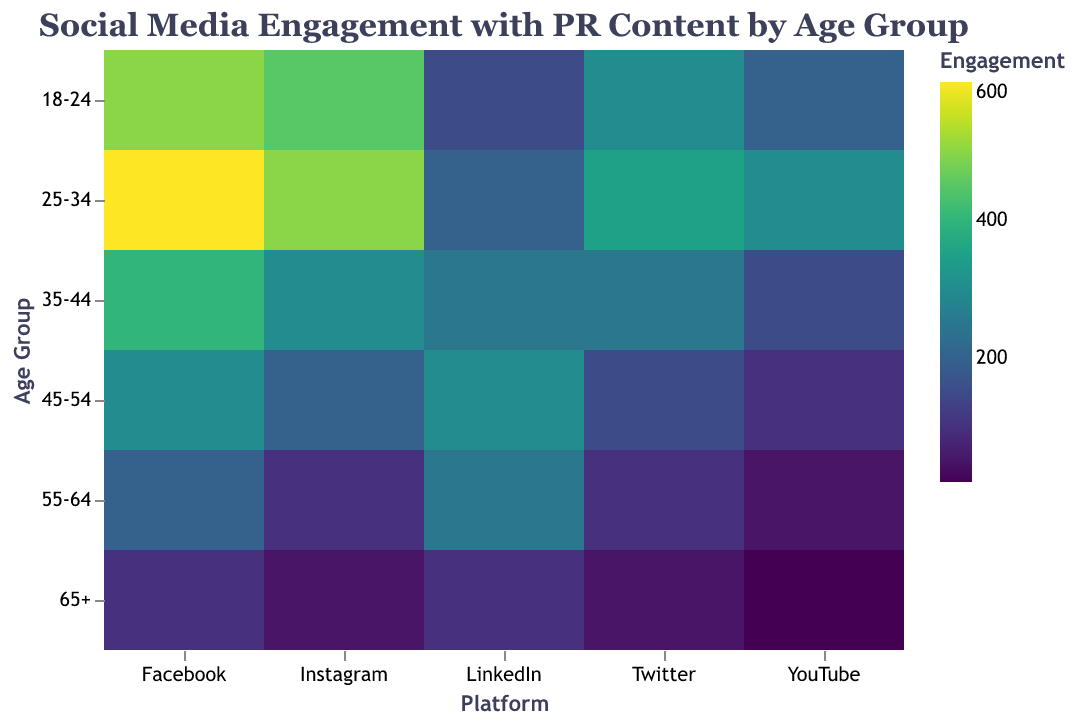What is the title of the heatmap? The title is located at the top of the heatmap and it states "Social Media Engagement with PR Content by Age Group".
Answer: Social Media Engagement with PR Content by Age Group Which age group has the highest engagement on Instagram? Look at the color intensity in the Instagram column and find the cell with the highest value, which corresponds to the age group 25-34.
Answer: 25-34 How many social media platforms are depicted in the heatmap? The number of unique labels on the x-axis corresponds to the number of social media platforms. Here, the labels are Facebook, Twitter, Instagram, LinkedIn, and YouTube, totaling 5 platforms.
Answer: 5 What is the engagement value for the age group 55-64 on LinkedIn? Find the row for the age group 55-64 and look at the color intensity under the LinkedIn column, which shows an engagement value of 250.
Answer: 250 Which age group has the lowest engagement on YouTube? Look at the color intensity in the YouTube column and identify the cell with the least intense color, corresponding to the age group 65+.
Answer: 65+ What age group has higher engagement on Twitter, 18-24 or 45-54? Compare the color intensities for Twitter engagement values between age groups 18-24 (300) and 45-54 (150).
Answer: 18-24 Calculate the average Facebook engagement across all age groups. Add all the Facebook engagement values for each age group (500 + 600 + 400 + 300 + 200 + 100 = 2100) and divide by the number of age groups (6).
Answer: 350 Which age group shows the least engagement on all social media platforms combined? Sum the engagement values across all platforms for each age group and compare them. Age group 65+ has 100 + 50 + 50 + 100 + 20 = 320, which is the lowest.
Answer: 65+ What is the difference in Instagram engagement between age groups 25-34 and 45-54? Subtract the Instagram engagement value for 45-54 (200) from 25-34 (500) giving 500 - 200.
Answer: 300 Which platform has the highest engagement value for age group 35-44? Look at the row for age group 35-44 and identify which platform column has the highest intensity color, which corresponds to Facebook with a value of 400.
Answer: Facebook 